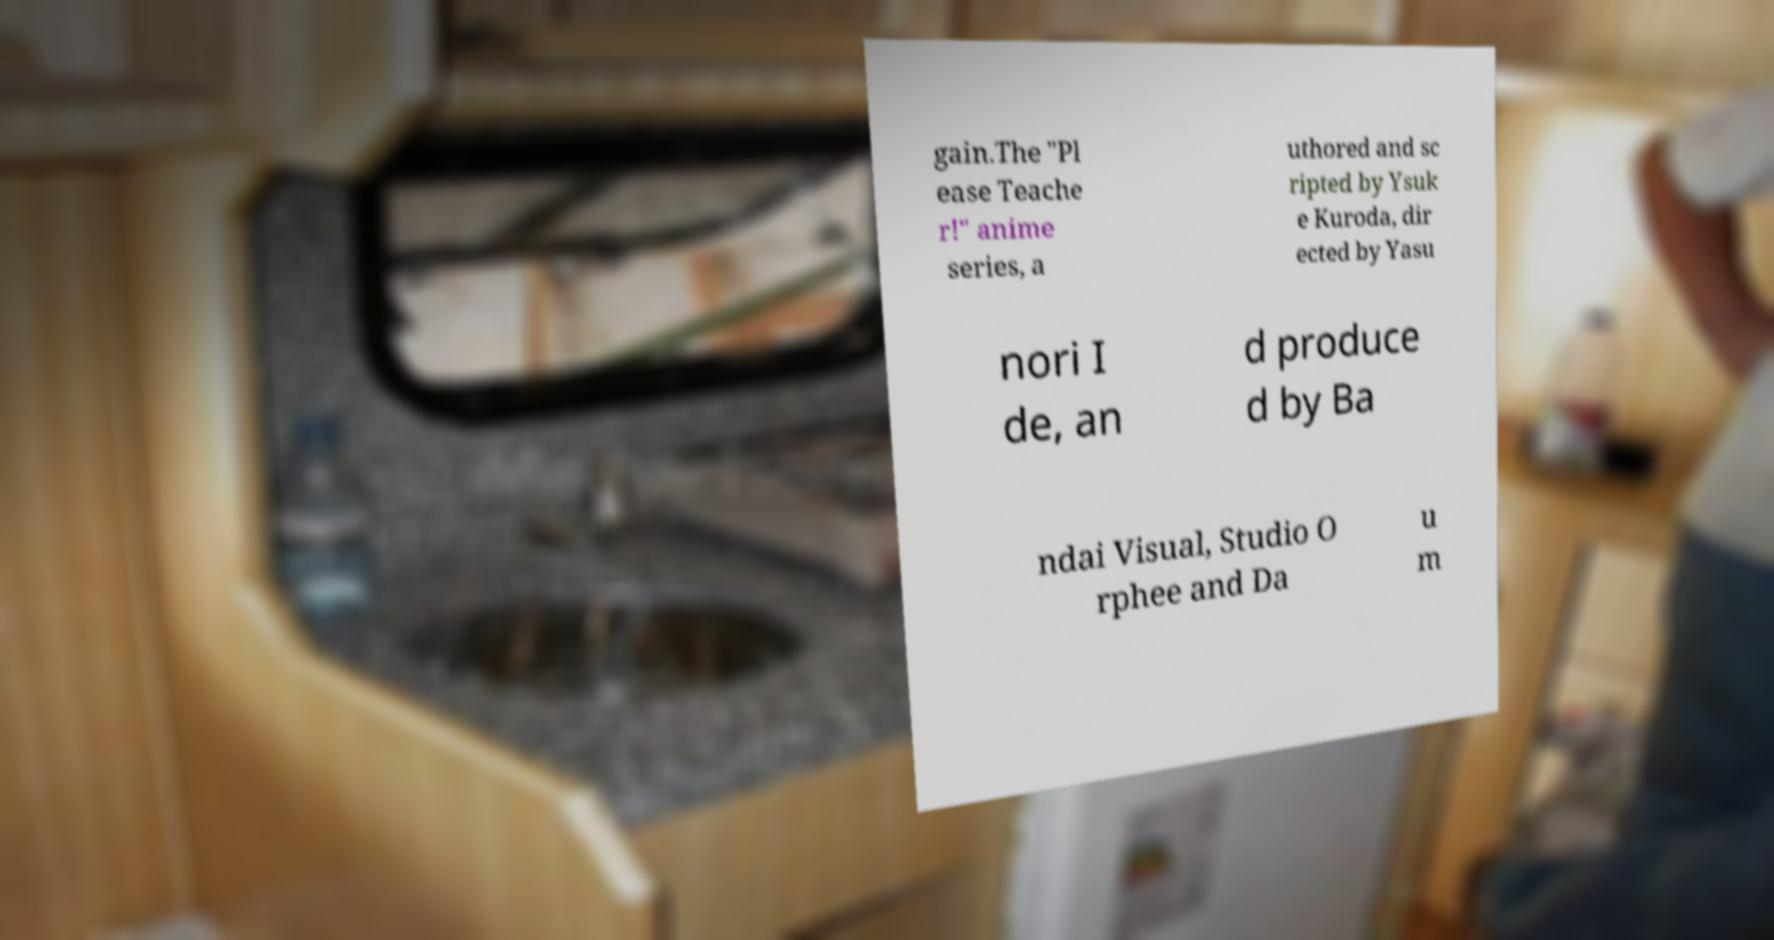Can you accurately transcribe the text from the provided image for me? gain.The "Pl ease Teache r!" anime series, a uthored and sc ripted by Ysuk e Kuroda, dir ected by Yasu nori I de, an d produce d by Ba ndai Visual, Studio O rphee and Da u m 